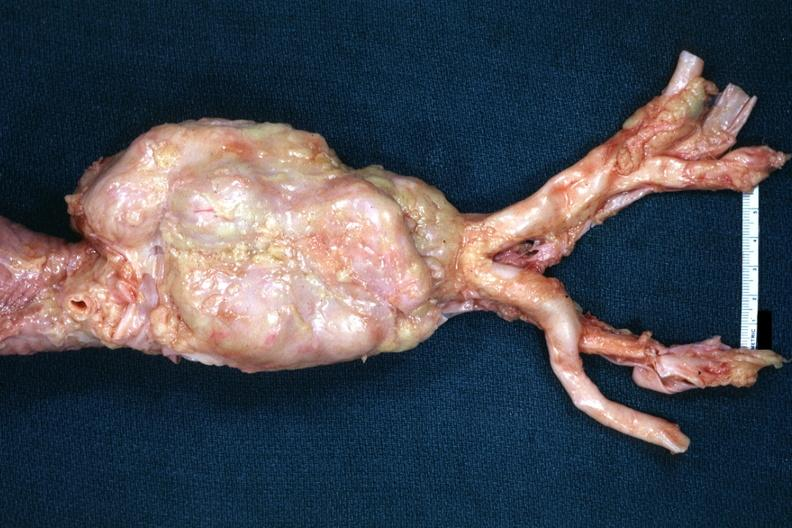what is present?
Answer the question using a single word or phrase. Lymph node 